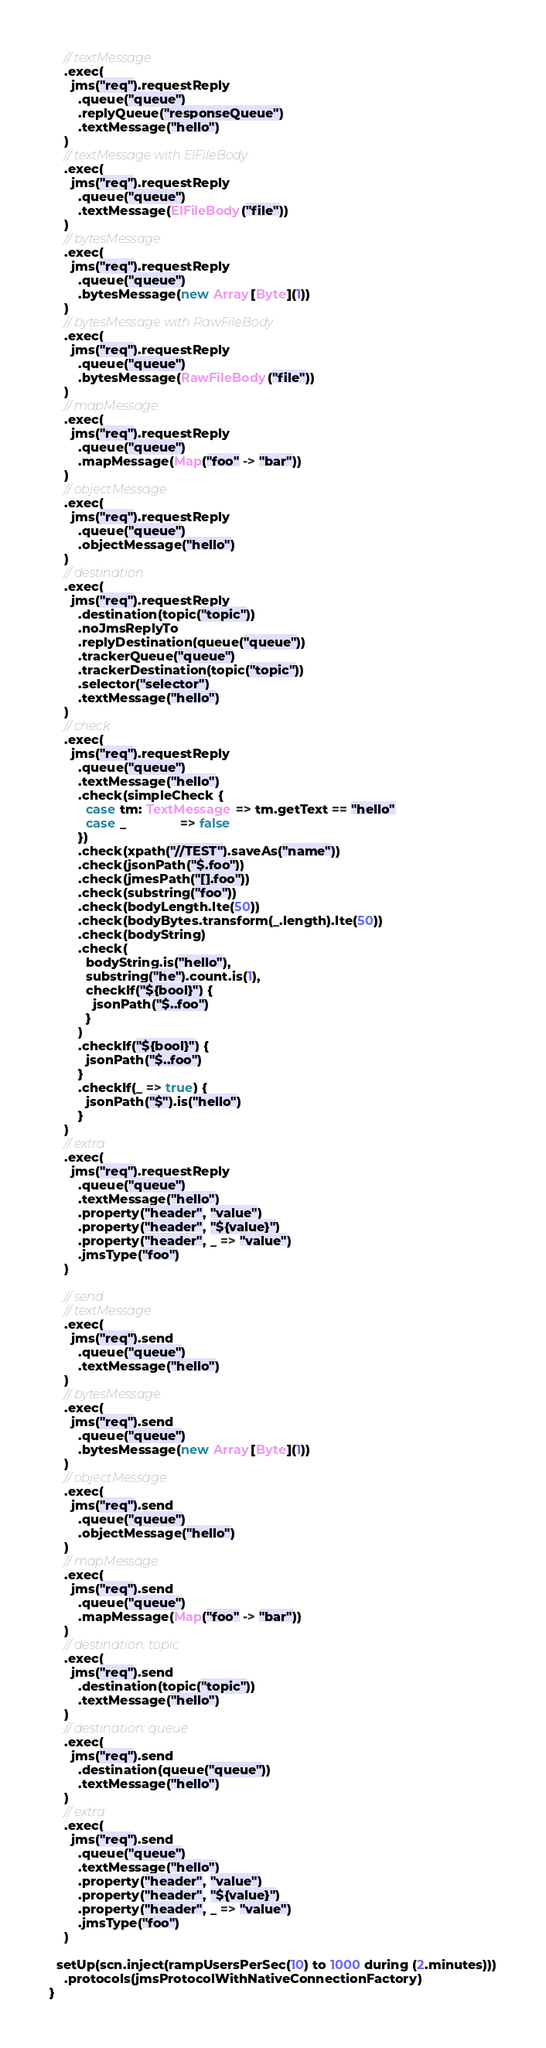Convert code to text. <code><loc_0><loc_0><loc_500><loc_500><_Scala_>    // textMessage
    .exec(
      jms("req").requestReply
        .queue("queue")
        .replyQueue("responseQueue")
        .textMessage("hello")
    )
    // textMessage with ElFileBody
    .exec(
      jms("req").requestReply
        .queue("queue")
        .textMessage(ElFileBody("file"))
    )
    // bytesMessage
    .exec(
      jms("req").requestReply
        .queue("queue")
        .bytesMessage(new Array[Byte](1))
    )
    // bytesMessage with RawFileBody
    .exec(
      jms("req").requestReply
        .queue("queue")
        .bytesMessage(RawFileBody("file"))
    )
    // mapMessage
    .exec(
      jms("req").requestReply
        .queue("queue")
        .mapMessage(Map("foo" -> "bar"))
    )
    // objectMessage
    .exec(
      jms("req").requestReply
        .queue("queue")
        .objectMessage("hello")
    )
    // destination
    .exec(
      jms("req").requestReply
        .destination(topic("topic"))
        .noJmsReplyTo
        .replyDestination(queue("queue"))
        .trackerQueue("queue")
        .trackerDestination(topic("topic"))
        .selector("selector")
        .textMessage("hello")
    )
    // check
    .exec(
      jms("req").requestReply
        .queue("queue")
        .textMessage("hello")
        .check(simpleCheck {
          case tm: TextMessage => tm.getText == "hello"
          case _               => false
        })
        .check(xpath("//TEST").saveAs("name"))
        .check(jsonPath("$.foo"))
        .check(jmesPath("[].foo"))
        .check(substring("foo"))
        .check(bodyLength.lte(50))
        .check(bodyBytes.transform(_.length).lte(50))
        .check(bodyString)
        .check(
          bodyString.is("hello"),
          substring("he").count.is(1),
          checkIf("${bool}") {
            jsonPath("$..foo")
          }
        )
        .checkIf("${bool}") {
          jsonPath("$..foo")
        }
        .checkIf(_ => true) {
          jsonPath("$").is("hello")
        }
    )
    // extra
    .exec(
      jms("req").requestReply
        .queue("queue")
        .textMessage("hello")
        .property("header", "value")
        .property("header", "${value}")
        .property("header", _ => "value")
        .jmsType("foo")
    )

    // send
    // textMessage
    .exec(
      jms("req").send
        .queue("queue")
        .textMessage("hello")
    )
    // bytesMessage
    .exec(
      jms("req").send
        .queue("queue")
        .bytesMessage(new Array[Byte](1))
    )
    // objectMessage
    .exec(
      jms("req").send
        .queue("queue")
        .objectMessage("hello")
    )
    // mapMessage
    .exec(
      jms("req").send
        .queue("queue")
        .mapMessage(Map("foo" -> "bar"))
    )
    // destination: topic
    .exec(
      jms("req").send
        .destination(topic("topic"))
        .textMessage("hello")
    )
    // destination: queue
    .exec(
      jms("req").send
        .destination(queue("queue"))
        .textMessage("hello")
    )
    // extra
    .exec(
      jms("req").send
        .queue("queue")
        .textMessage("hello")
        .property("header", "value")
        .property("header", "${value}")
        .property("header", _ => "value")
        .jmsType("foo")
    )

  setUp(scn.inject(rampUsersPerSec(10) to 1000 during (2.minutes)))
    .protocols(jmsProtocolWithNativeConnectionFactory)
}
</code> 